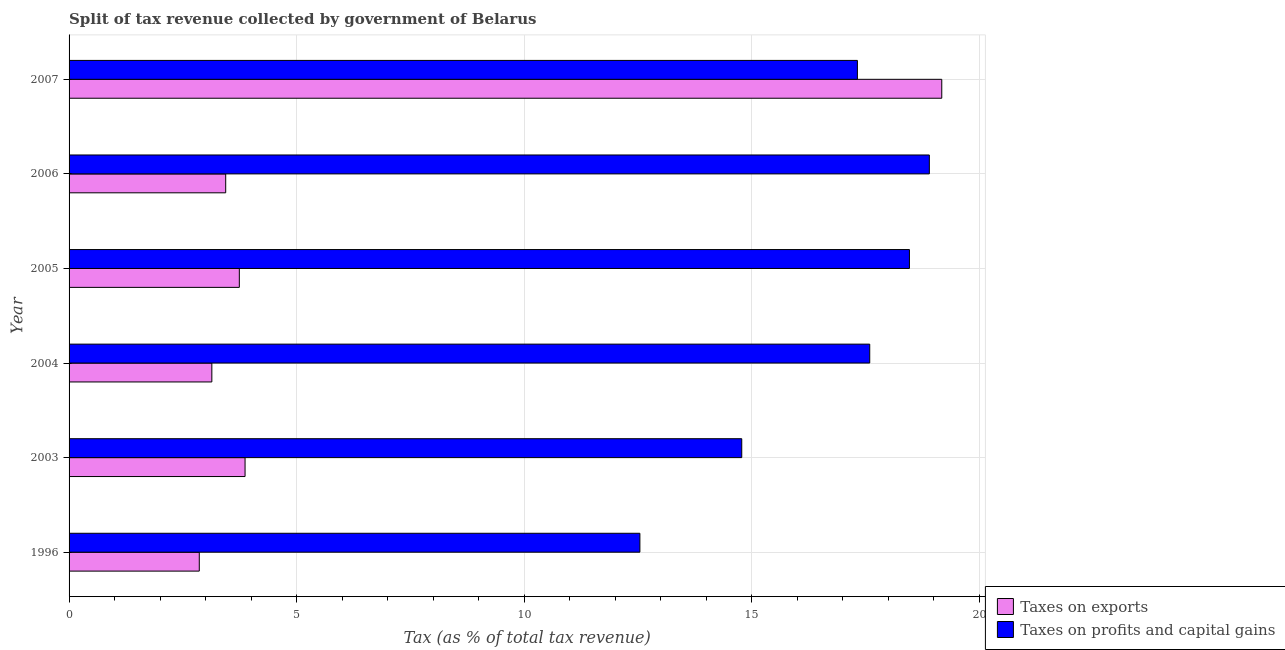How many different coloured bars are there?
Give a very brief answer. 2. Are the number of bars per tick equal to the number of legend labels?
Give a very brief answer. Yes. How many bars are there on the 2nd tick from the top?
Keep it short and to the point. 2. In how many cases, is the number of bars for a given year not equal to the number of legend labels?
Your answer should be very brief. 0. What is the percentage of revenue obtained from taxes on exports in 2003?
Provide a short and direct response. 3.87. Across all years, what is the maximum percentage of revenue obtained from taxes on exports?
Your answer should be compact. 19.17. Across all years, what is the minimum percentage of revenue obtained from taxes on exports?
Make the answer very short. 2.86. In which year was the percentage of revenue obtained from taxes on profits and capital gains maximum?
Offer a very short reply. 2006. In which year was the percentage of revenue obtained from taxes on profits and capital gains minimum?
Make the answer very short. 1996. What is the total percentage of revenue obtained from taxes on profits and capital gains in the graph?
Provide a short and direct response. 99.6. What is the difference between the percentage of revenue obtained from taxes on exports in 2003 and that in 2005?
Give a very brief answer. 0.13. What is the difference between the percentage of revenue obtained from taxes on profits and capital gains in 2003 and the percentage of revenue obtained from taxes on exports in 2004?
Offer a terse response. 11.64. What is the average percentage of revenue obtained from taxes on exports per year?
Keep it short and to the point. 6.04. In the year 2007, what is the difference between the percentage of revenue obtained from taxes on exports and percentage of revenue obtained from taxes on profits and capital gains?
Provide a short and direct response. 1.85. What is the ratio of the percentage of revenue obtained from taxes on exports in 2005 to that in 2007?
Keep it short and to the point. 0.2. Is the percentage of revenue obtained from taxes on profits and capital gains in 1996 less than that in 2005?
Provide a short and direct response. Yes. What is the difference between the highest and the second highest percentage of revenue obtained from taxes on exports?
Provide a succinct answer. 15.31. What is the difference between the highest and the lowest percentage of revenue obtained from taxes on exports?
Give a very brief answer. 16.31. In how many years, is the percentage of revenue obtained from taxes on profits and capital gains greater than the average percentage of revenue obtained from taxes on profits and capital gains taken over all years?
Offer a very short reply. 4. Is the sum of the percentage of revenue obtained from taxes on profits and capital gains in 2004 and 2005 greater than the maximum percentage of revenue obtained from taxes on exports across all years?
Make the answer very short. Yes. What does the 1st bar from the top in 1996 represents?
Provide a short and direct response. Taxes on profits and capital gains. What does the 1st bar from the bottom in 2005 represents?
Ensure brevity in your answer.  Taxes on exports. Are all the bars in the graph horizontal?
Your answer should be compact. Yes. How many years are there in the graph?
Give a very brief answer. 6. What is the difference between two consecutive major ticks on the X-axis?
Your answer should be compact. 5. Are the values on the major ticks of X-axis written in scientific E-notation?
Offer a terse response. No. Does the graph contain any zero values?
Provide a succinct answer. No. Does the graph contain grids?
Your response must be concise. Yes. Where does the legend appear in the graph?
Offer a terse response. Bottom right. What is the title of the graph?
Your answer should be compact. Split of tax revenue collected by government of Belarus. Does "Methane" appear as one of the legend labels in the graph?
Offer a terse response. No. What is the label or title of the X-axis?
Your answer should be very brief. Tax (as % of total tax revenue). What is the Tax (as % of total tax revenue) in Taxes on exports in 1996?
Offer a very short reply. 2.86. What is the Tax (as % of total tax revenue) in Taxes on profits and capital gains in 1996?
Provide a succinct answer. 12.54. What is the Tax (as % of total tax revenue) of Taxes on exports in 2003?
Your answer should be very brief. 3.87. What is the Tax (as % of total tax revenue) of Taxes on profits and capital gains in 2003?
Provide a short and direct response. 14.78. What is the Tax (as % of total tax revenue) in Taxes on exports in 2004?
Provide a succinct answer. 3.14. What is the Tax (as % of total tax revenue) in Taxes on profits and capital gains in 2004?
Offer a terse response. 17.59. What is the Tax (as % of total tax revenue) in Taxes on exports in 2005?
Ensure brevity in your answer.  3.74. What is the Tax (as % of total tax revenue) in Taxes on profits and capital gains in 2005?
Give a very brief answer. 18.46. What is the Tax (as % of total tax revenue) of Taxes on exports in 2006?
Make the answer very short. 3.44. What is the Tax (as % of total tax revenue) of Taxes on profits and capital gains in 2006?
Your answer should be very brief. 18.9. What is the Tax (as % of total tax revenue) of Taxes on exports in 2007?
Offer a very short reply. 19.17. What is the Tax (as % of total tax revenue) of Taxes on profits and capital gains in 2007?
Provide a short and direct response. 17.32. Across all years, what is the maximum Tax (as % of total tax revenue) of Taxes on exports?
Your answer should be compact. 19.17. Across all years, what is the maximum Tax (as % of total tax revenue) of Taxes on profits and capital gains?
Your answer should be compact. 18.9. Across all years, what is the minimum Tax (as % of total tax revenue) of Taxes on exports?
Your response must be concise. 2.86. Across all years, what is the minimum Tax (as % of total tax revenue) of Taxes on profits and capital gains?
Provide a succinct answer. 12.54. What is the total Tax (as % of total tax revenue) in Taxes on exports in the graph?
Provide a succinct answer. 36.22. What is the total Tax (as % of total tax revenue) in Taxes on profits and capital gains in the graph?
Give a very brief answer. 99.6. What is the difference between the Tax (as % of total tax revenue) in Taxes on exports in 1996 and that in 2003?
Your response must be concise. -1.01. What is the difference between the Tax (as % of total tax revenue) in Taxes on profits and capital gains in 1996 and that in 2003?
Keep it short and to the point. -2.24. What is the difference between the Tax (as % of total tax revenue) of Taxes on exports in 1996 and that in 2004?
Give a very brief answer. -0.28. What is the difference between the Tax (as % of total tax revenue) in Taxes on profits and capital gains in 1996 and that in 2004?
Provide a short and direct response. -5.05. What is the difference between the Tax (as % of total tax revenue) of Taxes on exports in 1996 and that in 2005?
Provide a succinct answer. -0.88. What is the difference between the Tax (as % of total tax revenue) in Taxes on profits and capital gains in 1996 and that in 2005?
Give a very brief answer. -5.92. What is the difference between the Tax (as % of total tax revenue) in Taxes on exports in 1996 and that in 2006?
Your answer should be very brief. -0.58. What is the difference between the Tax (as % of total tax revenue) in Taxes on profits and capital gains in 1996 and that in 2006?
Offer a terse response. -6.36. What is the difference between the Tax (as % of total tax revenue) of Taxes on exports in 1996 and that in 2007?
Ensure brevity in your answer.  -16.31. What is the difference between the Tax (as % of total tax revenue) of Taxes on profits and capital gains in 1996 and that in 2007?
Provide a succinct answer. -4.78. What is the difference between the Tax (as % of total tax revenue) in Taxes on exports in 2003 and that in 2004?
Keep it short and to the point. 0.73. What is the difference between the Tax (as % of total tax revenue) of Taxes on profits and capital gains in 2003 and that in 2004?
Make the answer very short. -2.81. What is the difference between the Tax (as % of total tax revenue) in Taxes on exports in 2003 and that in 2005?
Ensure brevity in your answer.  0.13. What is the difference between the Tax (as % of total tax revenue) in Taxes on profits and capital gains in 2003 and that in 2005?
Keep it short and to the point. -3.68. What is the difference between the Tax (as % of total tax revenue) in Taxes on exports in 2003 and that in 2006?
Your response must be concise. 0.43. What is the difference between the Tax (as % of total tax revenue) of Taxes on profits and capital gains in 2003 and that in 2006?
Provide a short and direct response. -4.12. What is the difference between the Tax (as % of total tax revenue) of Taxes on exports in 2003 and that in 2007?
Give a very brief answer. -15.31. What is the difference between the Tax (as % of total tax revenue) of Taxes on profits and capital gains in 2003 and that in 2007?
Your answer should be very brief. -2.54. What is the difference between the Tax (as % of total tax revenue) of Taxes on exports in 2004 and that in 2005?
Provide a short and direct response. -0.6. What is the difference between the Tax (as % of total tax revenue) of Taxes on profits and capital gains in 2004 and that in 2005?
Offer a terse response. -0.87. What is the difference between the Tax (as % of total tax revenue) in Taxes on exports in 2004 and that in 2006?
Ensure brevity in your answer.  -0.3. What is the difference between the Tax (as % of total tax revenue) of Taxes on profits and capital gains in 2004 and that in 2006?
Provide a succinct answer. -1.31. What is the difference between the Tax (as % of total tax revenue) of Taxes on exports in 2004 and that in 2007?
Provide a succinct answer. -16.04. What is the difference between the Tax (as % of total tax revenue) in Taxes on profits and capital gains in 2004 and that in 2007?
Provide a short and direct response. 0.27. What is the difference between the Tax (as % of total tax revenue) in Taxes on exports in 2005 and that in 2006?
Offer a very short reply. 0.3. What is the difference between the Tax (as % of total tax revenue) in Taxes on profits and capital gains in 2005 and that in 2006?
Provide a short and direct response. -0.44. What is the difference between the Tax (as % of total tax revenue) of Taxes on exports in 2005 and that in 2007?
Keep it short and to the point. -15.43. What is the difference between the Tax (as % of total tax revenue) in Taxes on profits and capital gains in 2005 and that in 2007?
Make the answer very short. 1.14. What is the difference between the Tax (as % of total tax revenue) in Taxes on exports in 2006 and that in 2007?
Your answer should be compact. -15.73. What is the difference between the Tax (as % of total tax revenue) in Taxes on profits and capital gains in 2006 and that in 2007?
Your answer should be compact. 1.58. What is the difference between the Tax (as % of total tax revenue) of Taxes on exports in 1996 and the Tax (as % of total tax revenue) of Taxes on profits and capital gains in 2003?
Give a very brief answer. -11.92. What is the difference between the Tax (as % of total tax revenue) in Taxes on exports in 1996 and the Tax (as % of total tax revenue) in Taxes on profits and capital gains in 2004?
Make the answer very short. -14.73. What is the difference between the Tax (as % of total tax revenue) of Taxes on exports in 1996 and the Tax (as % of total tax revenue) of Taxes on profits and capital gains in 2005?
Give a very brief answer. -15.6. What is the difference between the Tax (as % of total tax revenue) of Taxes on exports in 1996 and the Tax (as % of total tax revenue) of Taxes on profits and capital gains in 2006?
Give a very brief answer. -16.04. What is the difference between the Tax (as % of total tax revenue) in Taxes on exports in 1996 and the Tax (as % of total tax revenue) in Taxes on profits and capital gains in 2007?
Make the answer very short. -14.46. What is the difference between the Tax (as % of total tax revenue) in Taxes on exports in 2003 and the Tax (as % of total tax revenue) in Taxes on profits and capital gains in 2004?
Offer a very short reply. -13.72. What is the difference between the Tax (as % of total tax revenue) in Taxes on exports in 2003 and the Tax (as % of total tax revenue) in Taxes on profits and capital gains in 2005?
Ensure brevity in your answer.  -14.6. What is the difference between the Tax (as % of total tax revenue) in Taxes on exports in 2003 and the Tax (as % of total tax revenue) in Taxes on profits and capital gains in 2006?
Keep it short and to the point. -15.03. What is the difference between the Tax (as % of total tax revenue) in Taxes on exports in 2003 and the Tax (as % of total tax revenue) in Taxes on profits and capital gains in 2007?
Provide a succinct answer. -13.45. What is the difference between the Tax (as % of total tax revenue) in Taxes on exports in 2004 and the Tax (as % of total tax revenue) in Taxes on profits and capital gains in 2005?
Provide a succinct answer. -15.33. What is the difference between the Tax (as % of total tax revenue) of Taxes on exports in 2004 and the Tax (as % of total tax revenue) of Taxes on profits and capital gains in 2006?
Make the answer very short. -15.76. What is the difference between the Tax (as % of total tax revenue) of Taxes on exports in 2004 and the Tax (as % of total tax revenue) of Taxes on profits and capital gains in 2007?
Offer a very short reply. -14.18. What is the difference between the Tax (as % of total tax revenue) in Taxes on exports in 2005 and the Tax (as % of total tax revenue) in Taxes on profits and capital gains in 2006?
Offer a terse response. -15.16. What is the difference between the Tax (as % of total tax revenue) in Taxes on exports in 2005 and the Tax (as % of total tax revenue) in Taxes on profits and capital gains in 2007?
Your answer should be compact. -13.58. What is the difference between the Tax (as % of total tax revenue) in Taxes on exports in 2006 and the Tax (as % of total tax revenue) in Taxes on profits and capital gains in 2007?
Offer a terse response. -13.88. What is the average Tax (as % of total tax revenue) of Taxes on exports per year?
Offer a very short reply. 6.04. What is the average Tax (as % of total tax revenue) of Taxes on profits and capital gains per year?
Provide a succinct answer. 16.6. In the year 1996, what is the difference between the Tax (as % of total tax revenue) in Taxes on exports and Tax (as % of total tax revenue) in Taxes on profits and capital gains?
Your answer should be very brief. -9.68. In the year 2003, what is the difference between the Tax (as % of total tax revenue) of Taxes on exports and Tax (as % of total tax revenue) of Taxes on profits and capital gains?
Ensure brevity in your answer.  -10.91. In the year 2004, what is the difference between the Tax (as % of total tax revenue) of Taxes on exports and Tax (as % of total tax revenue) of Taxes on profits and capital gains?
Your answer should be very brief. -14.45. In the year 2005, what is the difference between the Tax (as % of total tax revenue) of Taxes on exports and Tax (as % of total tax revenue) of Taxes on profits and capital gains?
Provide a succinct answer. -14.72. In the year 2006, what is the difference between the Tax (as % of total tax revenue) of Taxes on exports and Tax (as % of total tax revenue) of Taxes on profits and capital gains?
Your answer should be very brief. -15.46. In the year 2007, what is the difference between the Tax (as % of total tax revenue) of Taxes on exports and Tax (as % of total tax revenue) of Taxes on profits and capital gains?
Give a very brief answer. 1.85. What is the ratio of the Tax (as % of total tax revenue) in Taxes on exports in 1996 to that in 2003?
Your answer should be compact. 0.74. What is the ratio of the Tax (as % of total tax revenue) in Taxes on profits and capital gains in 1996 to that in 2003?
Your response must be concise. 0.85. What is the ratio of the Tax (as % of total tax revenue) in Taxes on exports in 1996 to that in 2004?
Your response must be concise. 0.91. What is the ratio of the Tax (as % of total tax revenue) in Taxes on profits and capital gains in 1996 to that in 2004?
Keep it short and to the point. 0.71. What is the ratio of the Tax (as % of total tax revenue) in Taxes on exports in 1996 to that in 2005?
Your answer should be very brief. 0.76. What is the ratio of the Tax (as % of total tax revenue) in Taxes on profits and capital gains in 1996 to that in 2005?
Provide a succinct answer. 0.68. What is the ratio of the Tax (as % of total tax revenue) in Taxes on exports in 1996 to that in 2006?
Keep it short and to the point. 0.83. What is the ratio of the Tax (as % of total tax revenue) in Taxes on profits and capital gains in 1996 to that in 2006?
Your response must be concise. 0.66. What is the ratio of the Tax (as % of total tax revenue) of Taxes on exports in 1996 to that in 2007?
Your answer should be compact. 0.15. What is the ratio of the Tax (as % of total tax revenue) in Taxes on profits and capital gains in 1996 to that in 2007?
Your response must be concise. 0.72. What is the ratio of the Tax (as % of total tax revenue) of Taxes on exports in 2003 to that in 2004?
Offer a terse response. 1.23. What is the ratio of the Tax (as % of total tax revenue) of Taxes on profits and capital gains in 2003 to that in 2004?
Your answer should be compact. 0.84. What is the ratio of the Tax (as % of total tax revenue) in Taxes on exports in 2003 to that in 2005?
Keep it short and to the point. 1.03. What is the ratio of the Tax (as % of total tax revenue) in Taxes on profits and capital gains in 2003 to that in 2005?
Provide a succinct answer. 0.8. What is the ratio of the Tax (as % of total tax revenue) in Taxes on exports in 2003 to that in 2006?
Your response must be concise. 1.12. What is the ratio of the Tax (as % of total tax revenue) of Taxes on profits and capital gains in 2003 to that in 2006?
Keep it short and to the point. 0.78. What is the ratio of the Tax (as % of total tax revenue) in Taxes on exports in 2003 to that in 2007?
Your answer should be very brief. 0.2. What is the ratio of the Tax (as % of total tax revenue) in Taxes on profits and capital gains in 2003 to that in 2007?
Provide a succinct answer. 0.85. What is the ratio of the Tax (as % of total tax revenue) of Taxes on exports in 2004 to that in 2005?
Your answer should be very brief. 0.84. What is the ratio of the Tax (as % of total tax revenue) in Taxes on profits and capital gains in 2004 to that in 2005?
Your response must be concise. 0.95. What is the ratio of the Tax (as % of total tax revenue) in Taxes on exports in 2004 to that in 2006?
Your answer should be compact. 0.91. What is the ratio of the Tax (as % of total tax revenue) of Taxes on profits and capital gains in 2004 to that in 2006?
Your answer should be very brief. 0.93. What is the ratio of the Tax (as % of total tax revenue) in Taxes on exports in 2004 to that in 2007?
Ensure brevity in your answer.  0.16. What is the ratio of the Tax (as % of total tax revenue) of Taxes on profits and capital gains in 2004 to that in 2007?
Offer a terse response. 1.02. What is the ratio of the Tax (as % of total tax revenue) in Taxes on exports in 2005 to that in 2006?
Ensure brevity in your answer.  1.09. What is the ratio of the Tax (as % of total tax revenue) of Taxes on profits and capital gains in 2005 to that in 2006?
Make the answer very short. 0.98. What is the ratio of the Tax (as % of total tax revenue) of Taxes on exports in 2005 to that in 2007?
Ensure brevity in your answer.  0.2. What is the ratio of the Tax (as % of total tax revenue) in Taxes on profits and capital gains in 2005 to that in 2007?
Ensure brevity in your answer.  1.07. What is the ratio of the Tax (as % of total tax revenue) of Taxes on exports in 2006 to that in 2007?
Your response must be concise. 0.18. What is the ratio of the Tax (as % of total tax revenue) in Taxes on profits and capital gains in 2006 to that in 2007?
Make the answer very short. 1.09. What is the difference between the highest and the second highest Tax (as % of total tax revenue) of Taxes on exports?
Your response must be concise. 15.31. What is the difference between the highest and the second highest Tax (as % of total tax revenue) in Taxes on profits and capital gains?
Provide a short and direct response. 0.44. What is the difference between the highest and the lowest Tax (as % of total tax revenue) of Taxes on exports?
Keep it short and to the point. 16.31. What is the difference between the highest and the lowest Tax (as % of total tax revenue) of Taxes on profits and capital gains?
Give a very brief answer. 6.36. 